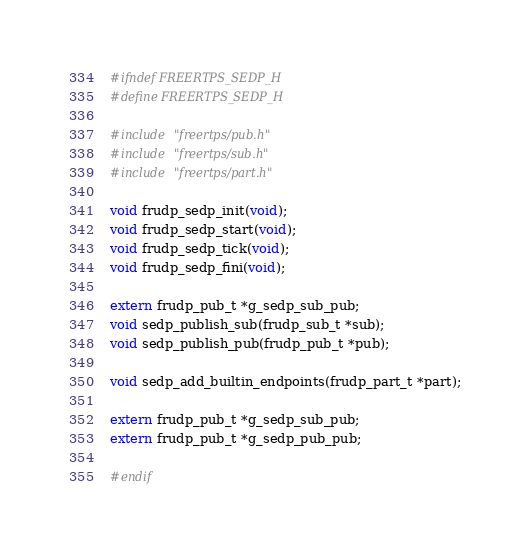Convert code to text. <code><loc_0><loc_0><loc_500><loc_500><_C_>#ifndef FREERTPS_SEDP_H
#define FREERTPS_SEDP_H

#include "freertps/pub.h"
#include "freertps/sub.h"
#include "freertps/part.h"

void frudp_sedp_init(void);
void frudp_sedp_start(void);
void frudp_sedp_tick(void);
void frudp_sedp_fini(void);

extern frudp_pub_t *g_sedp_sub_pub;
void sedp_publish_sub(frudp_sub_t *sub);
void sedp_publish_pub(frudp_pub_t *pub);

void sedp_add_builtin_endpoints(frudp_part_t *part);

extern frudp_pub_t *g_sedp_sub_pub;
extern frudp_pub_t *g_sedp_pub_pub;

#endif
</code> 